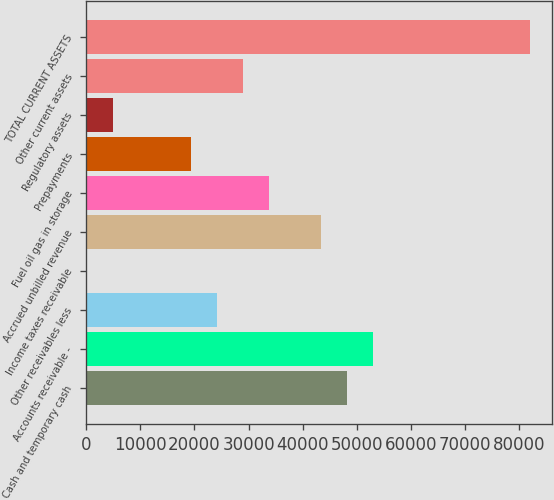Convert chart to OTSL. <chart><loc_0><loc_0><loc_500><loc_500><bar_chart><fcel>Cash and temporary cash<fcel>Accounts receivable -<fcel>Other receivables less<fcel>Income taxes receivable<fcel>Accrued unbilled revenue<fcel>Fuel oil gas in storage<fcel>Prepayments<fcel>Regulatory assets<fcel>Other current assets<fcel>TOTAL CURRENT ASSETS<nl><fcel>48255<fcel>53072.6<fcel>24167<fcel>79<fcel>43437.4<fcel>33802.2<fcel>19349.4<fcel>4896.6<fcel>28984.6<fcel>81978.2<nl></chart> 